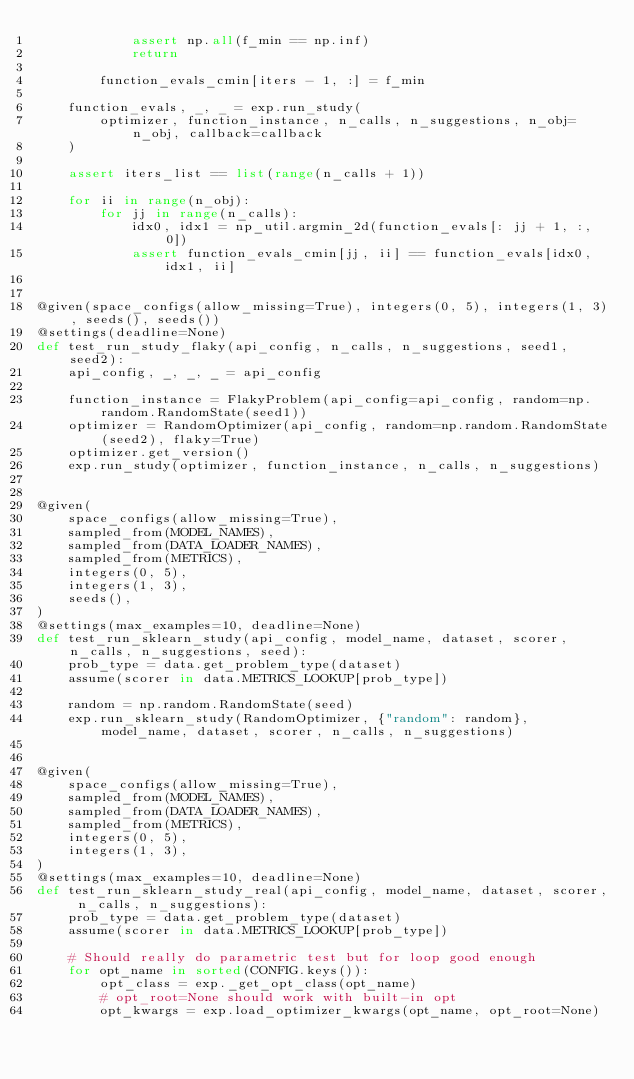<code> <loc_0><loc_0><loc_500><loc_500><_Python_>            assert np.all(f_min == np.inf)
            return

        function_evals_cmin[iters - 1, :] = f_min

    function_evals, _, _ = exp.run_study(
        optimizer, function_instance, n_calls, n_suggestions, n_obj=n_obj, callback=callback
    )

    assert iters_list == list(range(n_calls + 1))

    for ii in range(n_obj):
        for jj in range(n_calls):
            idx0, idx1 = np_util.argmin_2d(function_evals[: jj + 1, :, 0])
            assert function_evals_cmin[jj, ii] == function_evals[idx0, idx1, ii]


@given(space_configs(allow_missing=True), integers(0, 5), integers(1, 3), seeds(), seeds())
@settings(deadline=None)
def test_run_study_flaky(api_config, n_calls, n_suggestions, seed1, seed2):
    api_config, _, _, _ = api_config

    function_instance = FlakyProblem(api_config=api_config, random=np.random.RandomState(seed1))
    optimizer = RandomOptimizer(api_config, random=np.random.RandomState(seed2), flaky=True)
    optimizer.get_version()
    exp.run_study(optimizer, function_instance, n_calls, n_suggestions)


@given(
    space_configs(allow_missing=True),
    sampled_from(MODEL_NAMES),
    sampled_from(DATA_LOADER_NAMES),
    sampled_from(METRICS),
    integers(0, 5),
    integers(1, 3),
    seeds(),
)
@settings(max_examples=10, deadline=None)
def test_run_sklearn_study(api_config, model_name, dataset, scorer, n_calls, n_suggestions, seed):
    prob_type = data.get_problem_type(dataset)
    assume(scorer in data.METRICS_LOOKUP[prob_type])

    random = np.random.RandomState(seed)
    exp.run_sklearn_study(RandomOptimizer, {"random": random}, model_name, dataset, scorer, n_calls, n_suggestions)


@given(
    space_configs(allow_missing=True),
    sampled_from(MODEL_NAMES),
    sampled_from(DATA_LOADER_NAMES),
    sampled_from(METRICS),
    integers(0, 5),
    integers(1, 3),
)
@settings(max_examples=10, deadline=None)
def test_run_sklearn_study_real(api_config, model_name, dataset, scorer, n_calls, n_suggestions):
    prob_type = data.get_problem_type(dataset)
    assume(scorer in data.METRICS_LOOKUP[prob_type])

    # Should really do parametric test but for loop good enough
    for opt_name in sorted(CONFIG.keys()):
        opt_class = exp._get_opt_class(opt_name)
        # opt_root=None should work with built-in opt
        opt_kwargs = exp.load_optimizer_kwargs(opt_name, opt_root=None)
</code> 